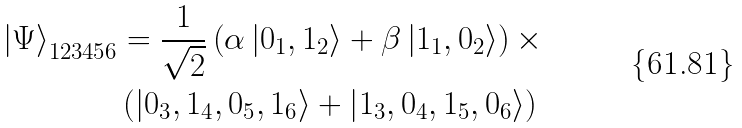<formula> <loc_0><loc_0><loc_500><loc_500>\left | \Psi \right \rangle _ { 1 2 3 4 5 6 } & = \frac { 1 } { \sqrt { 2 } } \left ( \alpha \left | 0 _ { 1 } , 1 _ { 2 } \right \rangle + \beta \left | 1 _ { 1 } , 0 _ { 2 } \right \rangle \right ) \times \\ & \left ( \left | 0 _ { 3 } , 1 _ { 4 } , 0 _ { 5 } , 1 _ { 6 } \right \rangle + \left | 1 _ { 3 } , 0 _ { 4 } , 1 _ { 5 } , 0 _ { 6 } \right \rangle \right )</formula> 